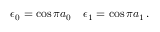Convert formula to latex. <formula><loc_0><loc_0><loc_500><loc_500>\epsilon _ { 0 } = \cos \pi a _ { 0 } \quad \epsilon _ { 1 } = \cos \pi a _ { 1 } \, .</formula> 